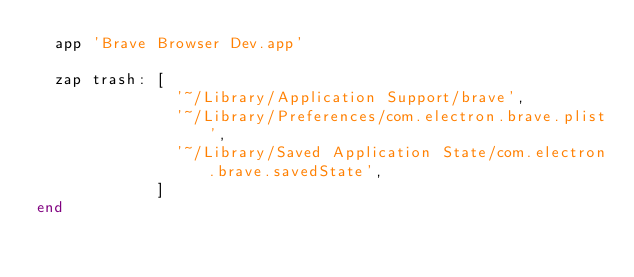<code> <loc_0><loc_0><loc_500><loc_500><_Ruby_>  app 'Brave Browser Dev.app'

  zap trash: [
               '~/Library/Application Support/brave',
               '~/Library/Preferences/com.electron.brave.plist',
               '~/Library/Saved Application State/com.electron.brave.savedState',
             ]
end
</code> 